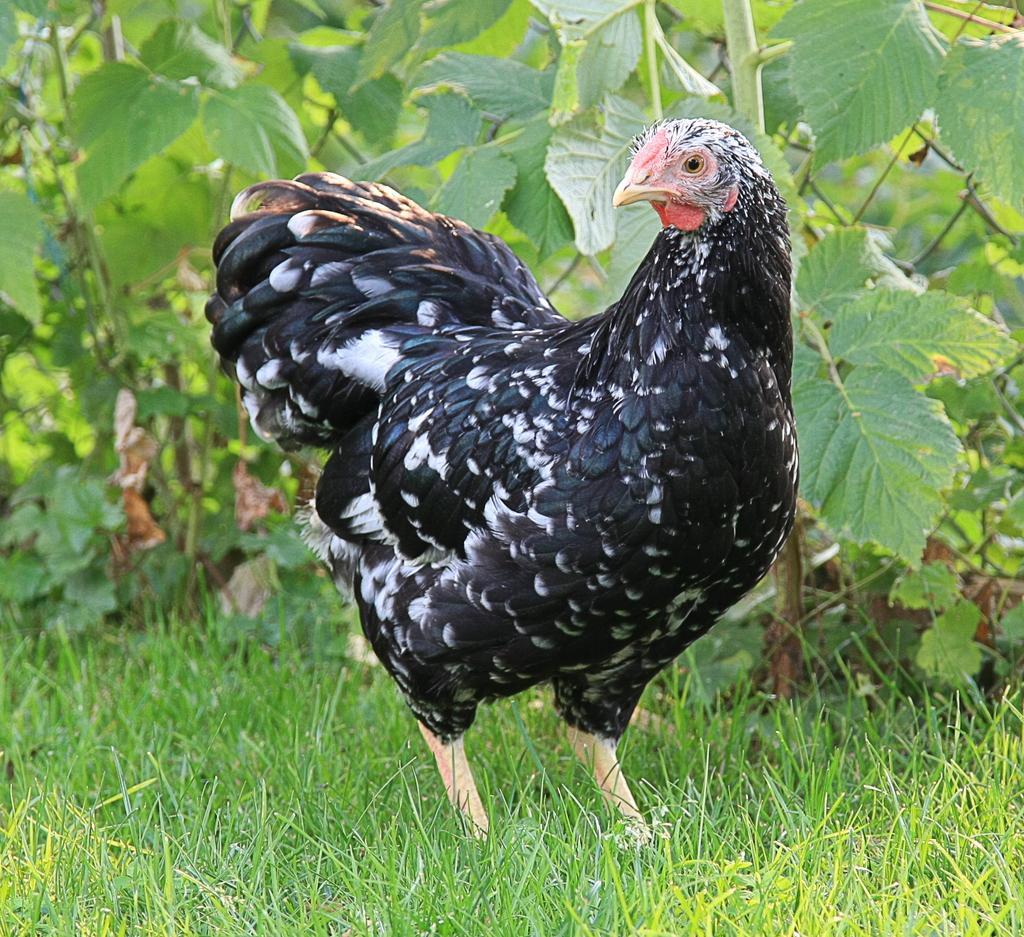Can you describe this image briefly? We can see hen on the grass,behind this then we can see plants. 